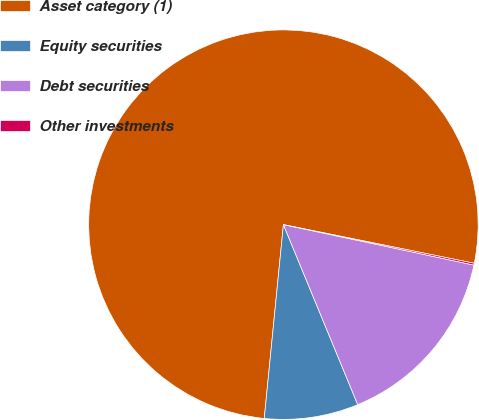<chart> <loc_0><loc_0><loc_500><loc_500><pie_chart><fcel>Asset category (1)<fcel>Equity securities<fcel>Debt securities<fcel>Other investments<nl><fcel>76.61%<fcel>7.8%<fcel>15.44%<fcel>0.15%<nl></chart> 